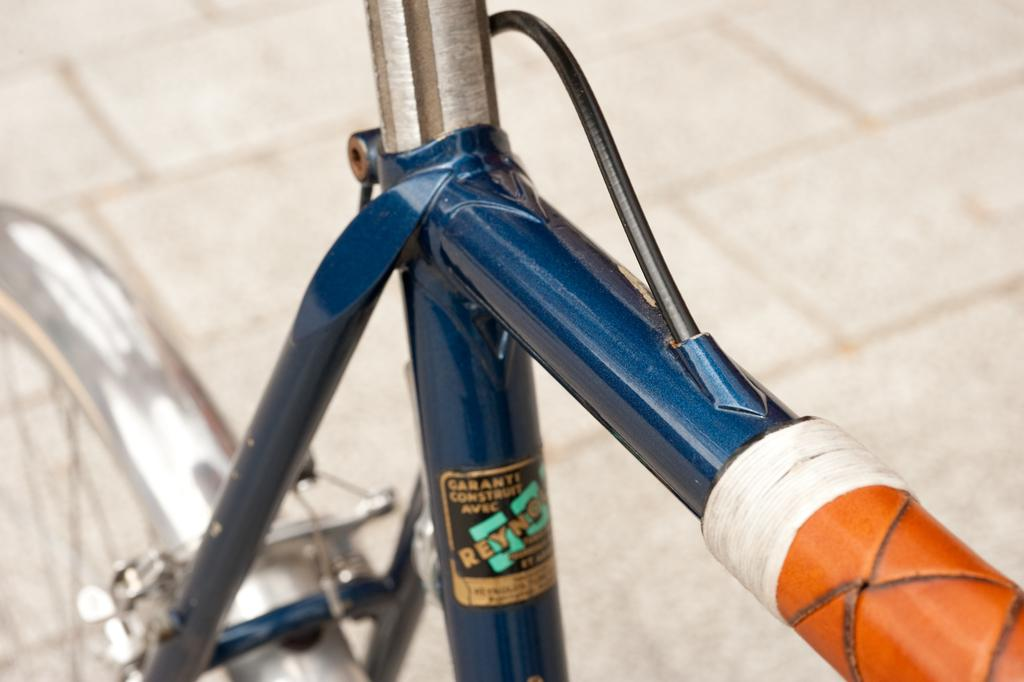What is partially visible in the picture? There is a partial image of a cycle in the picture. What objects can be seen besides the cycle? Three rods and a wheel are visible in the picture. What type of rings can be seen on the cycle in the image? There are no rings visible on the cycle in the image. What is the weather like in the image? The weather cannot be determined from the image, as it only shows a partial image of a cycle and other objects. 